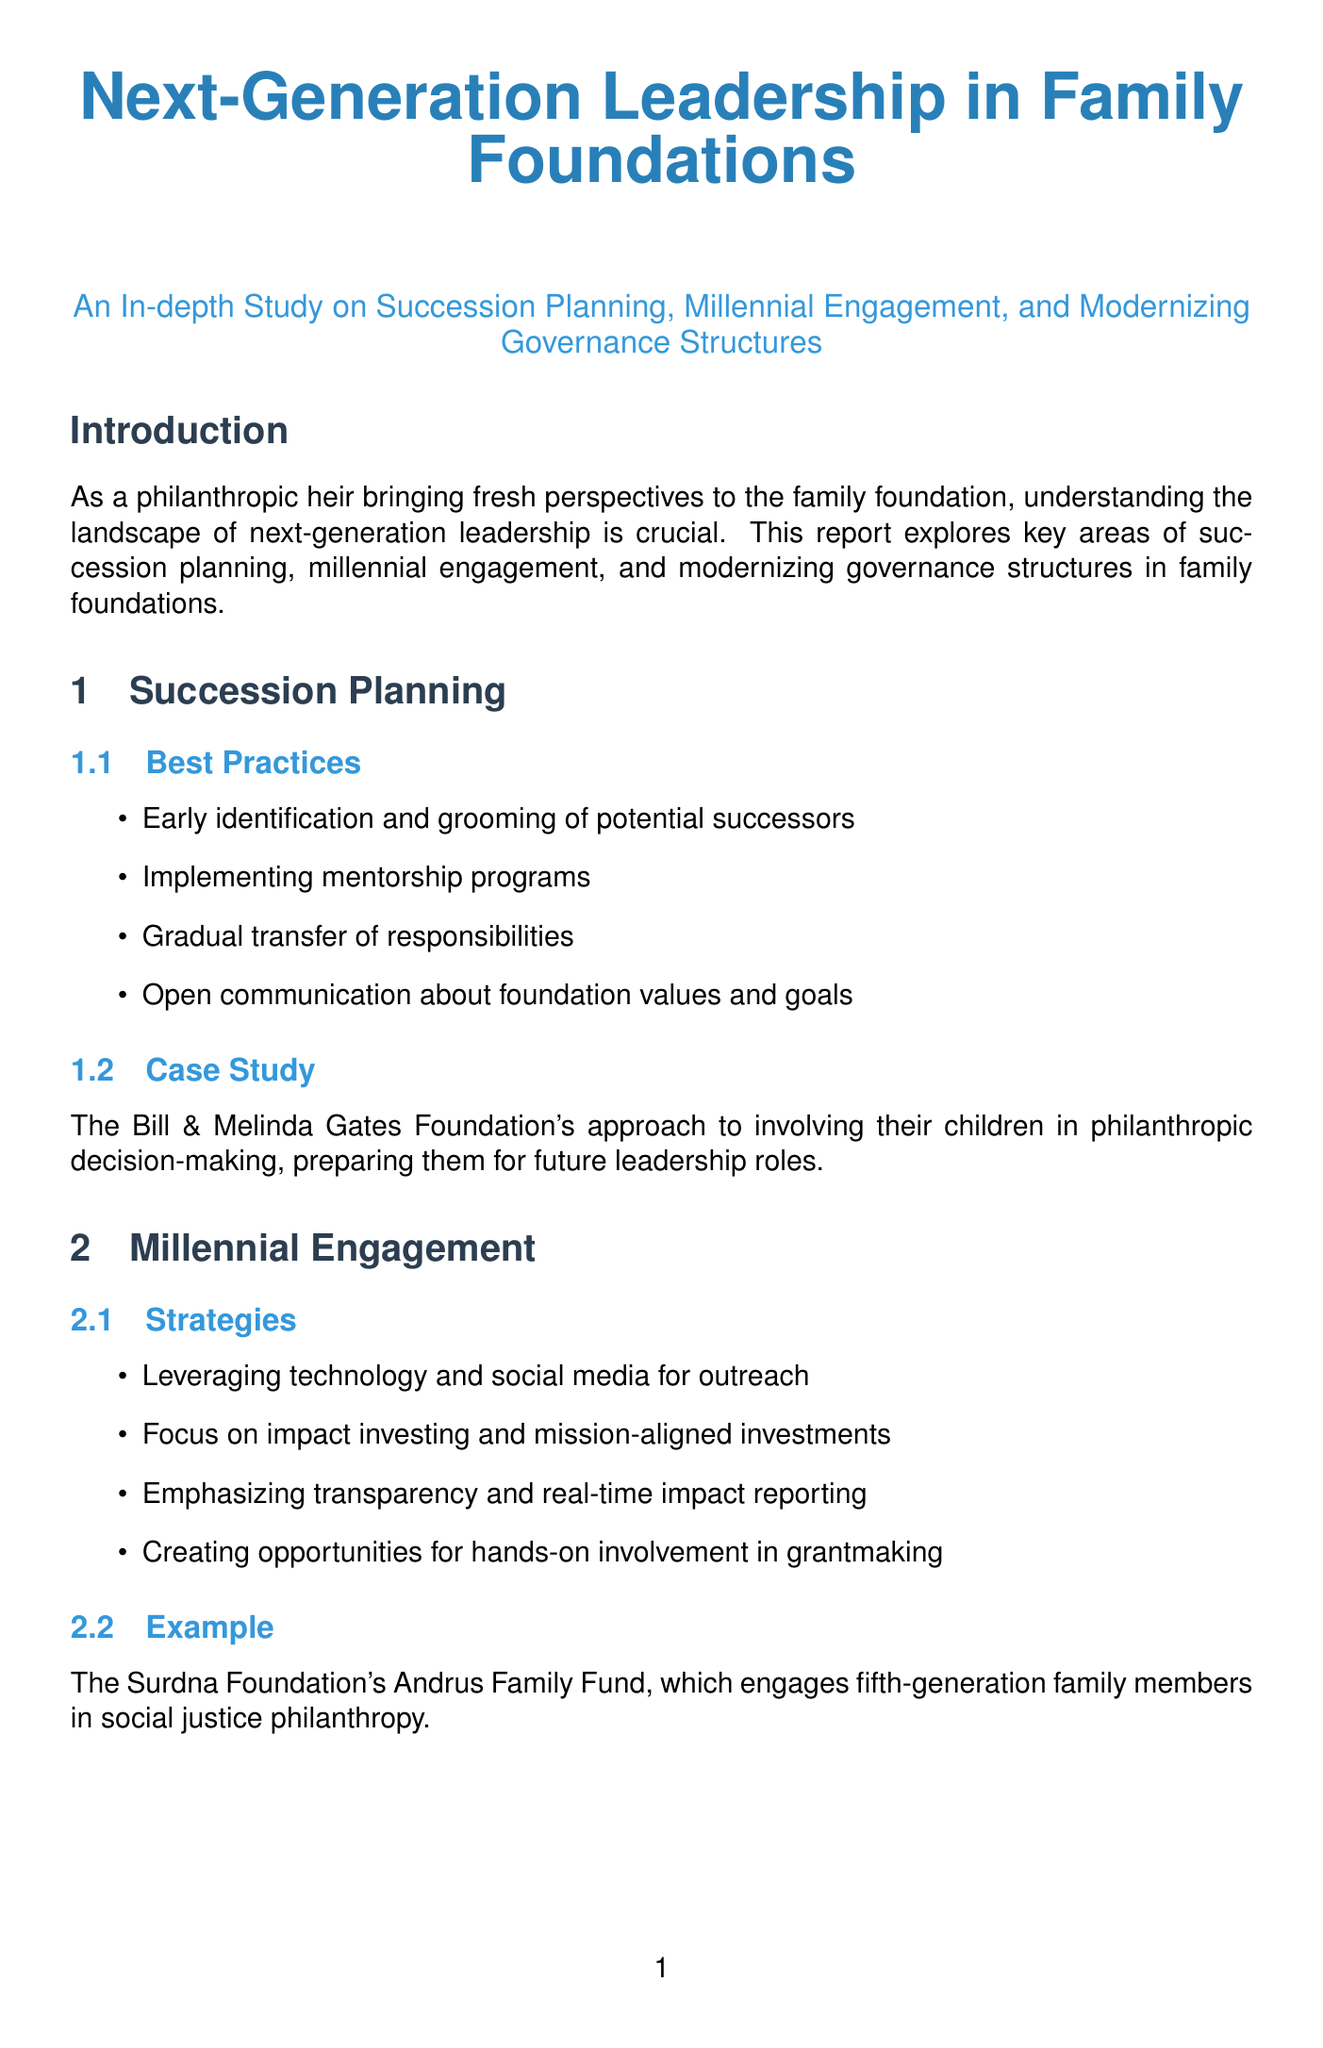What is the main focus of this report? The report explores key areas of succession planning, millennial engagement, and modernizing governance structures in family foundations.
Answer: Succession planning, millennial engagement, and modernizing governance structures What organization is highlighted in the case study for succession planning? The case study discusses the approach of the Bill & Melinda Gates Foundation in succession planning.
Answer: Bill & Melinda Gates Foundation Which foundation is mentioned as an example of millennial engagement? The Surdna Foundation’s Andrus Family Fund engages fifth-generation family members in social justice philanthropy.
Answer: Surdna Foundation What is one of the key components in modernizing governance structures? Among the key components listed, implementing term limits for board members is mentioned as a best practice.
Answer: Implementing term limits What challenge might next-generation leaders face according to the report? Next-generation leaders may face resistance to change from older family members.
Answer: Resistance to change How many future trends are identified in the document? The document lists four future trends for family foundations.
Answer: Four What role does artificial intelligence play in the innovation spotlight? The Rockefeller Foundation uses data analytics and AI in grant evaluation and impact assessment.
Answer: Data analytics and AI Who are the authors of "Next Gen Donors"? The authors of "Next Gen Donors" are Sharna Goldseker and Michael Moody.
Answer: Sharna Goldseker and Michael Moody 